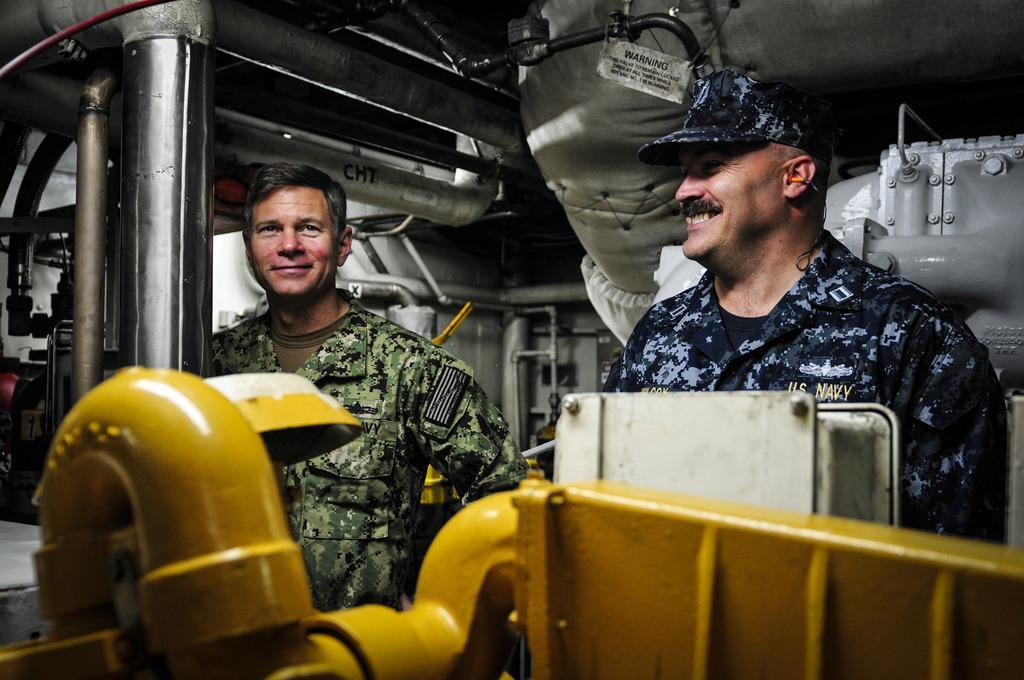In one or two sentences, can you explain what this image depicts? In this picture I can see two people with a smile. I can see metal pipes. 